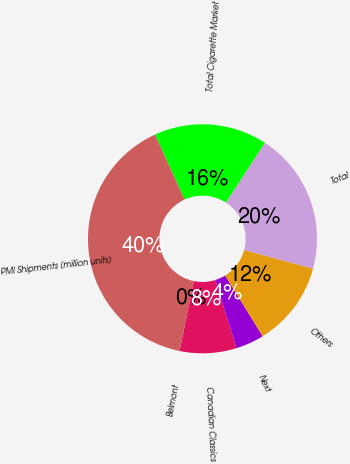<chart> <loc_0><loc_0><loc_500><loc_500><pie_chart><fcel>Total Cigarette Market<fcel>PMI Shipments (million units)<fcel>Belmont<fcel>Canadian Classics<fcel>Next<fcel>Others<fcel>Total<nl><fcel>16.0%<fcel>39.98%<fcel>0.01%<fcel>8.0%<fcel>4.01%<fcel>12.0%<fcel>20.0%<nl></chart> 